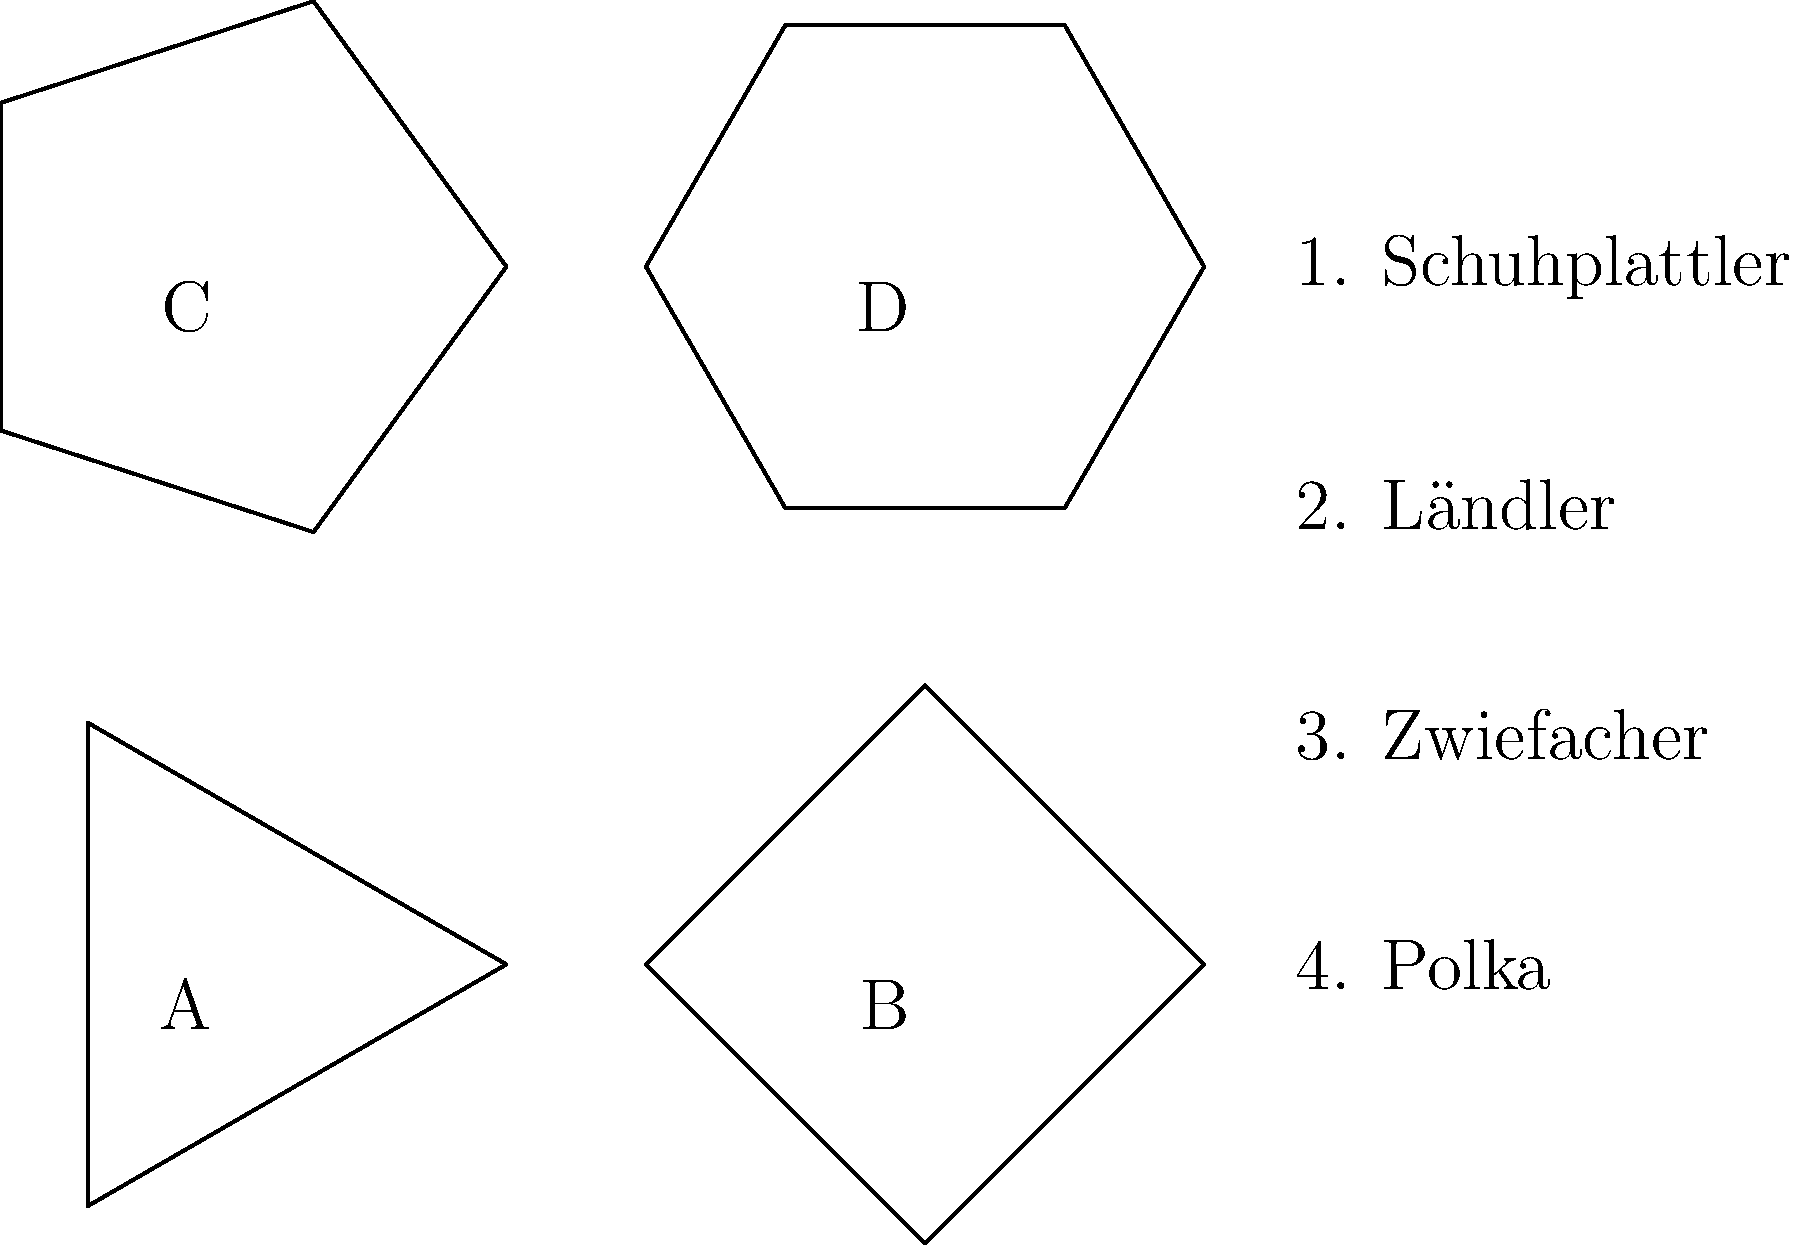Match the German folk dance patterns (A, B, C, D) to their corresponding dance names (1, 2, 3, 4). Which pattern corresponds to the Ländler dance? To answer this question, let's analyze each dance pattern and match it to the most likely corresponding dance:

1. Pattern A: Triangle (3 sides)
   This simple pattern likely represents a basic dance, possibly the Polka.

2. Pattern B: Square (4 sides)
   The square pattern is more structured, which could represent the Ländler, a slow waltz-like dance.

3. Pattern C: Pentagon (5 sides)
   This more complex pattern might represent the Zwiefacher, known for its changing rhythm.

4. Pattern D: Hexagon (6 sides)
   The most intricate pattern likely represents the Schuhplattler, known for its complex steps and hand movements.

Based on this analysis, we can deduce that the square pattern (B) most likely corresponds to the Ländler dance.
Answer: B 